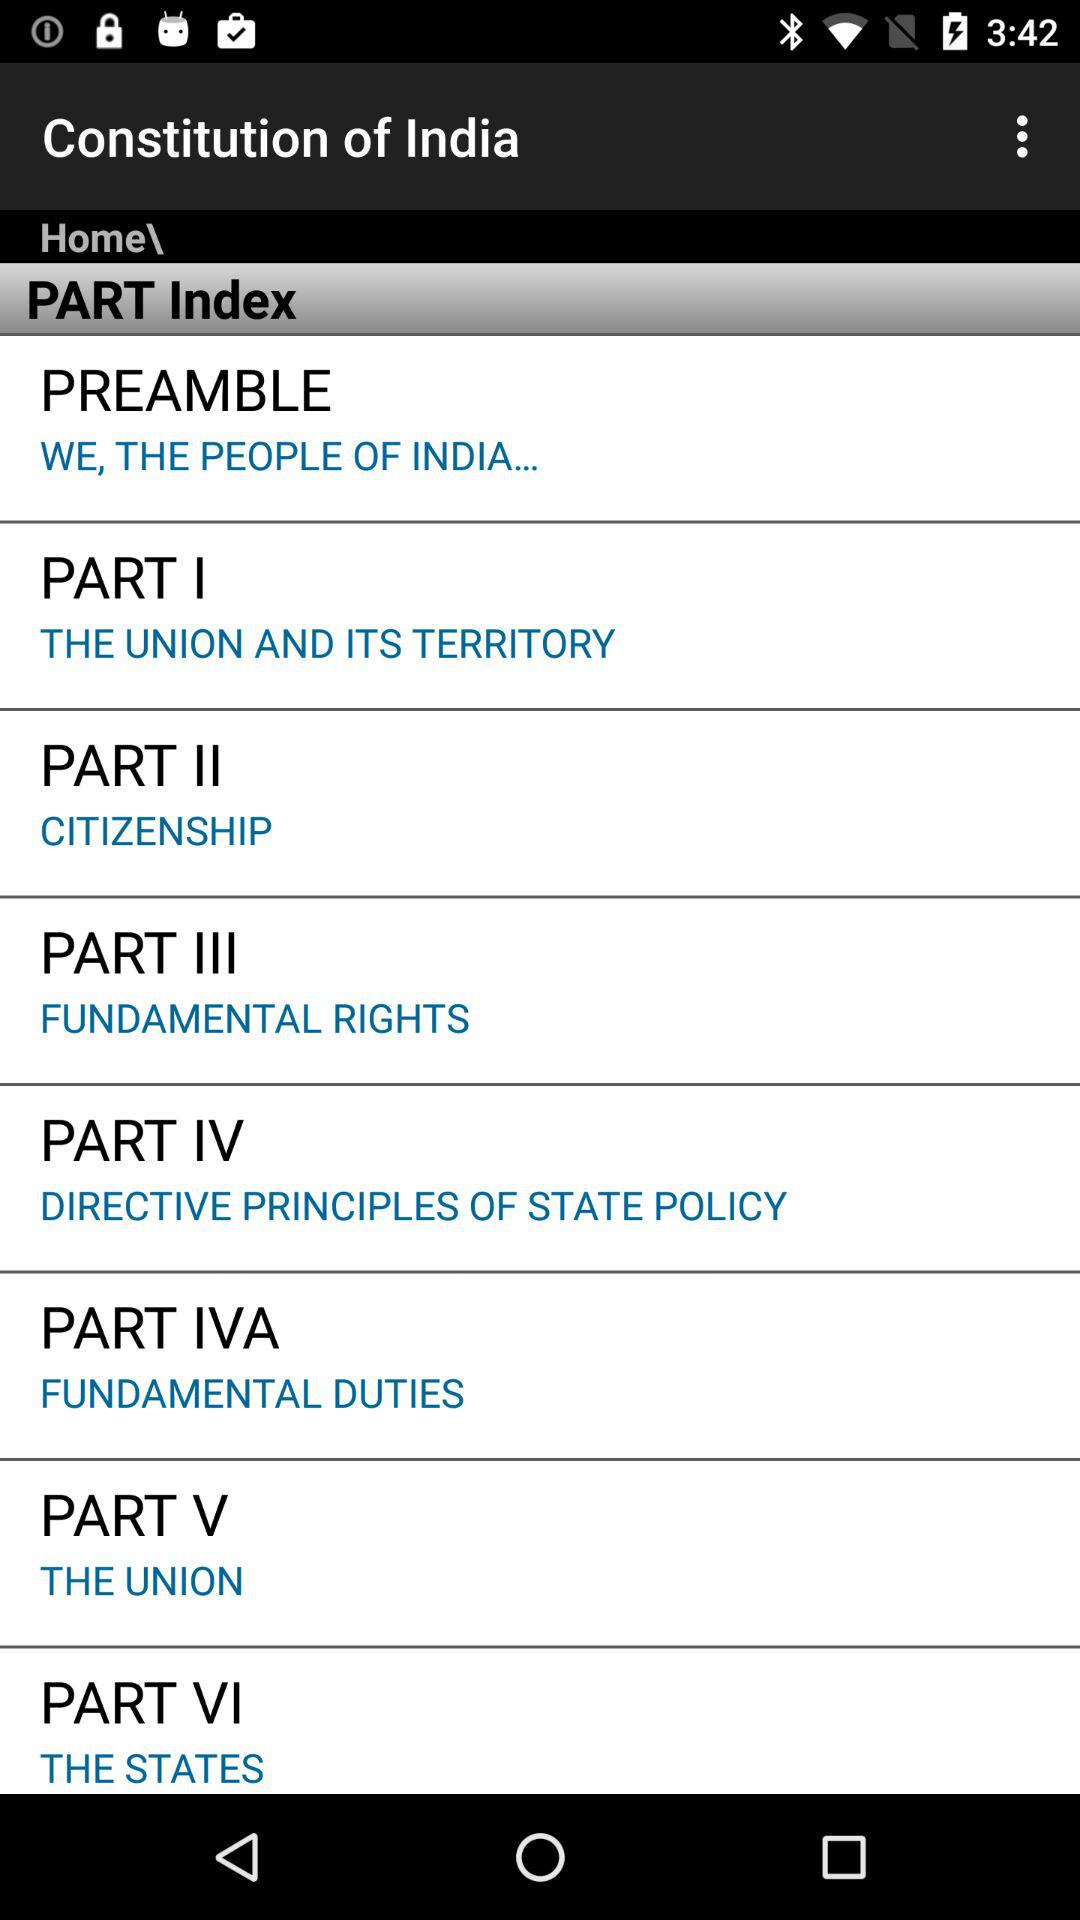Which parts of the Indian Constitution are shown in the index? The shown parts are "PREAMBLE", "PART I", "PART II", "PART III", "PART IV", "PART IVA", "PART V" and "PART VI". 